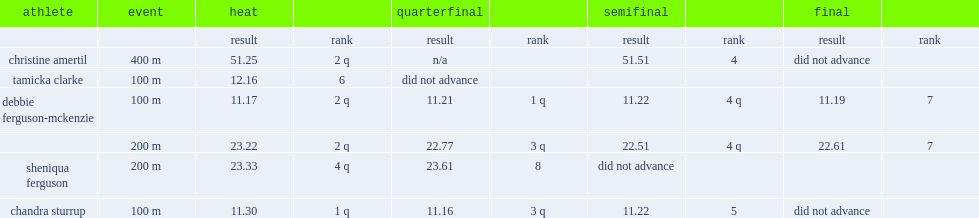What was the result that debbie ferguson-mckenzie got in the 200m event in the semifinal? 22.51. Parse the full table. {'header': ['athlete', 'event', 'heat', '', 'quarterfinal', '', 'semifinal', '', 'final', ''], 'rows': [['', '', 'result', 'rank', 'result', 'rank', 'result', 'rank', 'result', 'rank'], ['christine amertil', '400 m', '51.25', '2 q', 'n/a', '', '51.51', '4', 'did not advance', ''], ['tamicka clarke', '100 m', '12.16', '6', 'did not advance', '', '', '', '', ''], ['debbie ferguson-mckenzie', '100 m', '11.17', '2 q', '11.21', '1 q', '11.22', '4 q', '11.19', '7'], ['', '200 m', '23.22', '2 q', '22.77', '3 q', '22.51', '4 q', '22.61', '7'], ['sheniqua ferguson', '200 m', '23.33', '4 q', '23.61', '8', 'did not advance', '', '', ''], ['chandra sturrup', '100 m', '11.30', '1 q', '11.16', '3 q', '11.22', '5', 'did not advance', '']]} 